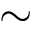<formula> <loc_0><loc_0><loc_500><loc_500>\sim</formula> 